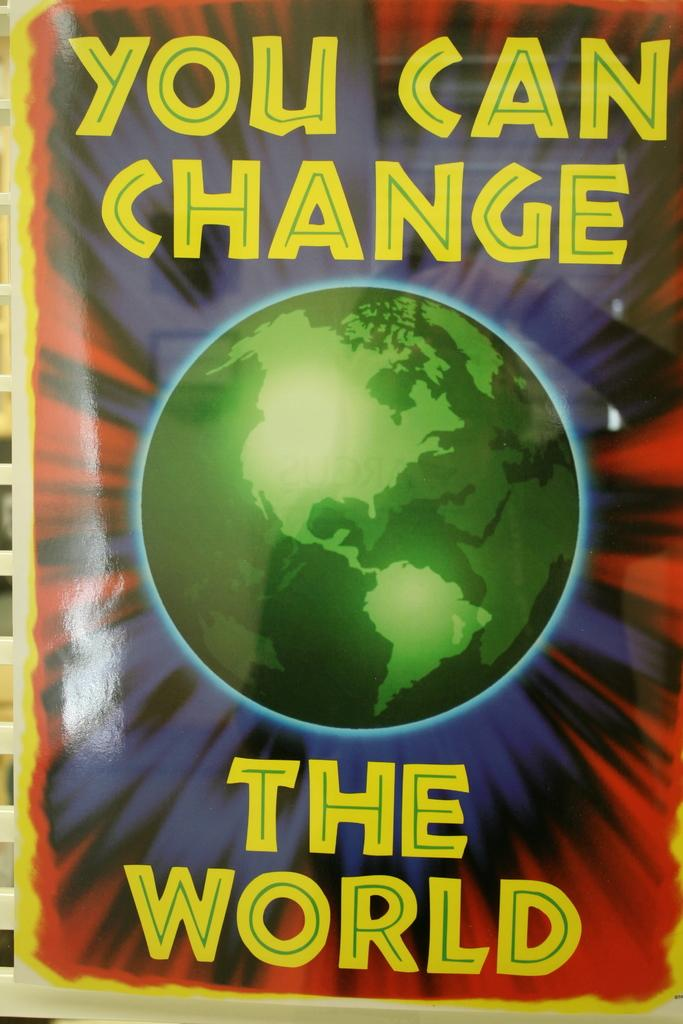<image>
Provide a brief description of the given image. A picture proclaims that You Can Change The World. 